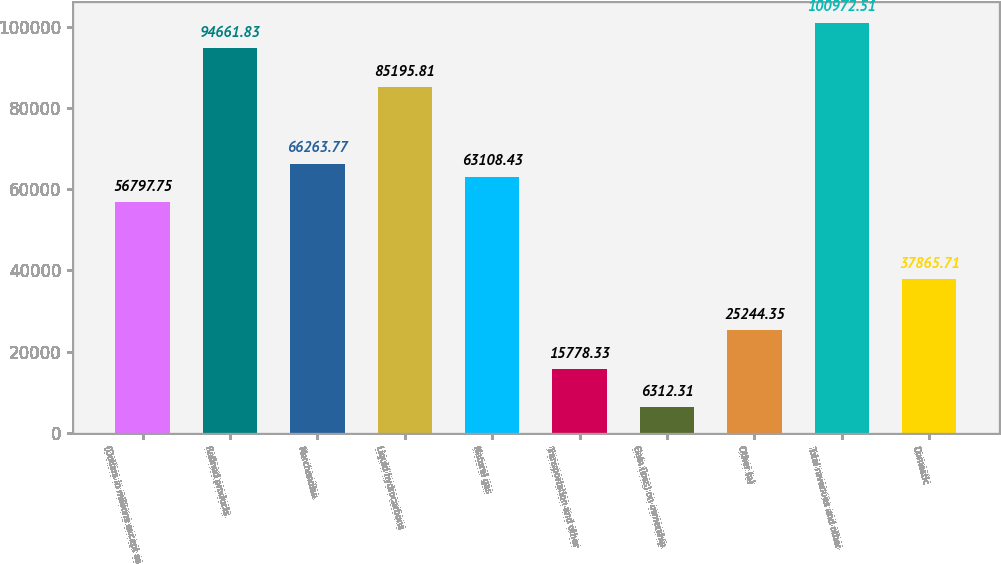<chart> <loc_0><loc_0><loc_500><loc_500><bar_chart><fcel>(Dollars in millions except as<fcel>Refined products<fcel>Merchandise<fcel>Liquid hydrocarbons<fcel>Natural gas<fcel>Transportation and other<fcel>Gain (loss) on ownership<fcel>Other (a)<fcel>Total revenues and other<fcel>Domestic<nl><fcel>56797.8<fcel>94661.8<fcel>66263.8<fcel>85195.8<fcel>63108.4<fcel>15778.3<fcel>6312.31<fcel>25244.3<fcel>100973<fcel>37865.7<nl></chart> 